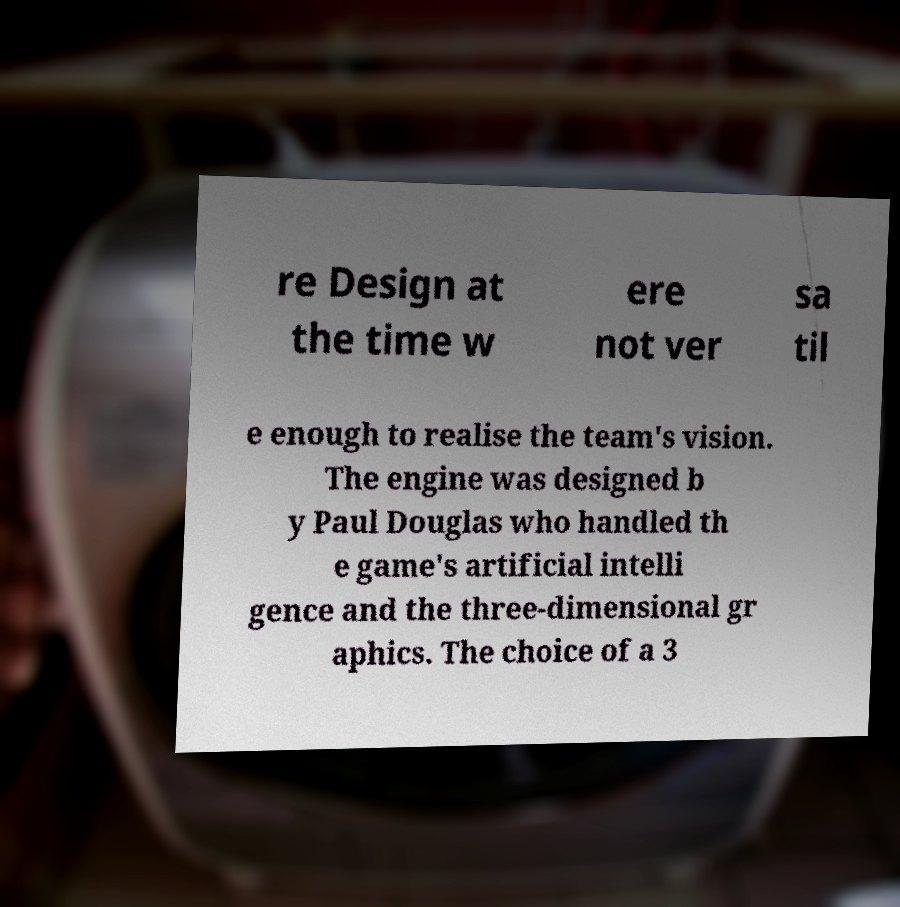Could you extract and type out the text from this image? re Design at the time w ere not ver sa til e enough to realise the team's vision. The engine was designed b y Paul Douglas who handled th e game's artificial intelli gence and the three-dimensional gr aphics. The choice of a 3 